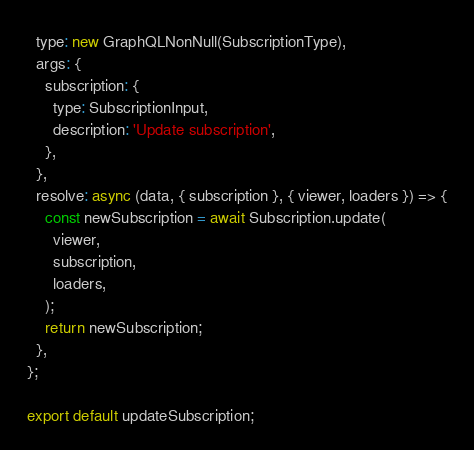<code> <loc_0><loc_0><loc_500><loc_500><_JavaScript_>  type: new GraphQLNonNull(SubscriptionType),
  args: {
    subscription: {
      type: SubscriptionInput,
      description: 'Update subscription',
    },
  },
  resolve: async (data, { subscription }, { viewer, loaders }) => {
    const newSubscription = await Subscription.update(
      viewer,
      subscription,
      loaders,
    );
    return newSubscription;
  },
};

export default updateSubscription;
</code> 